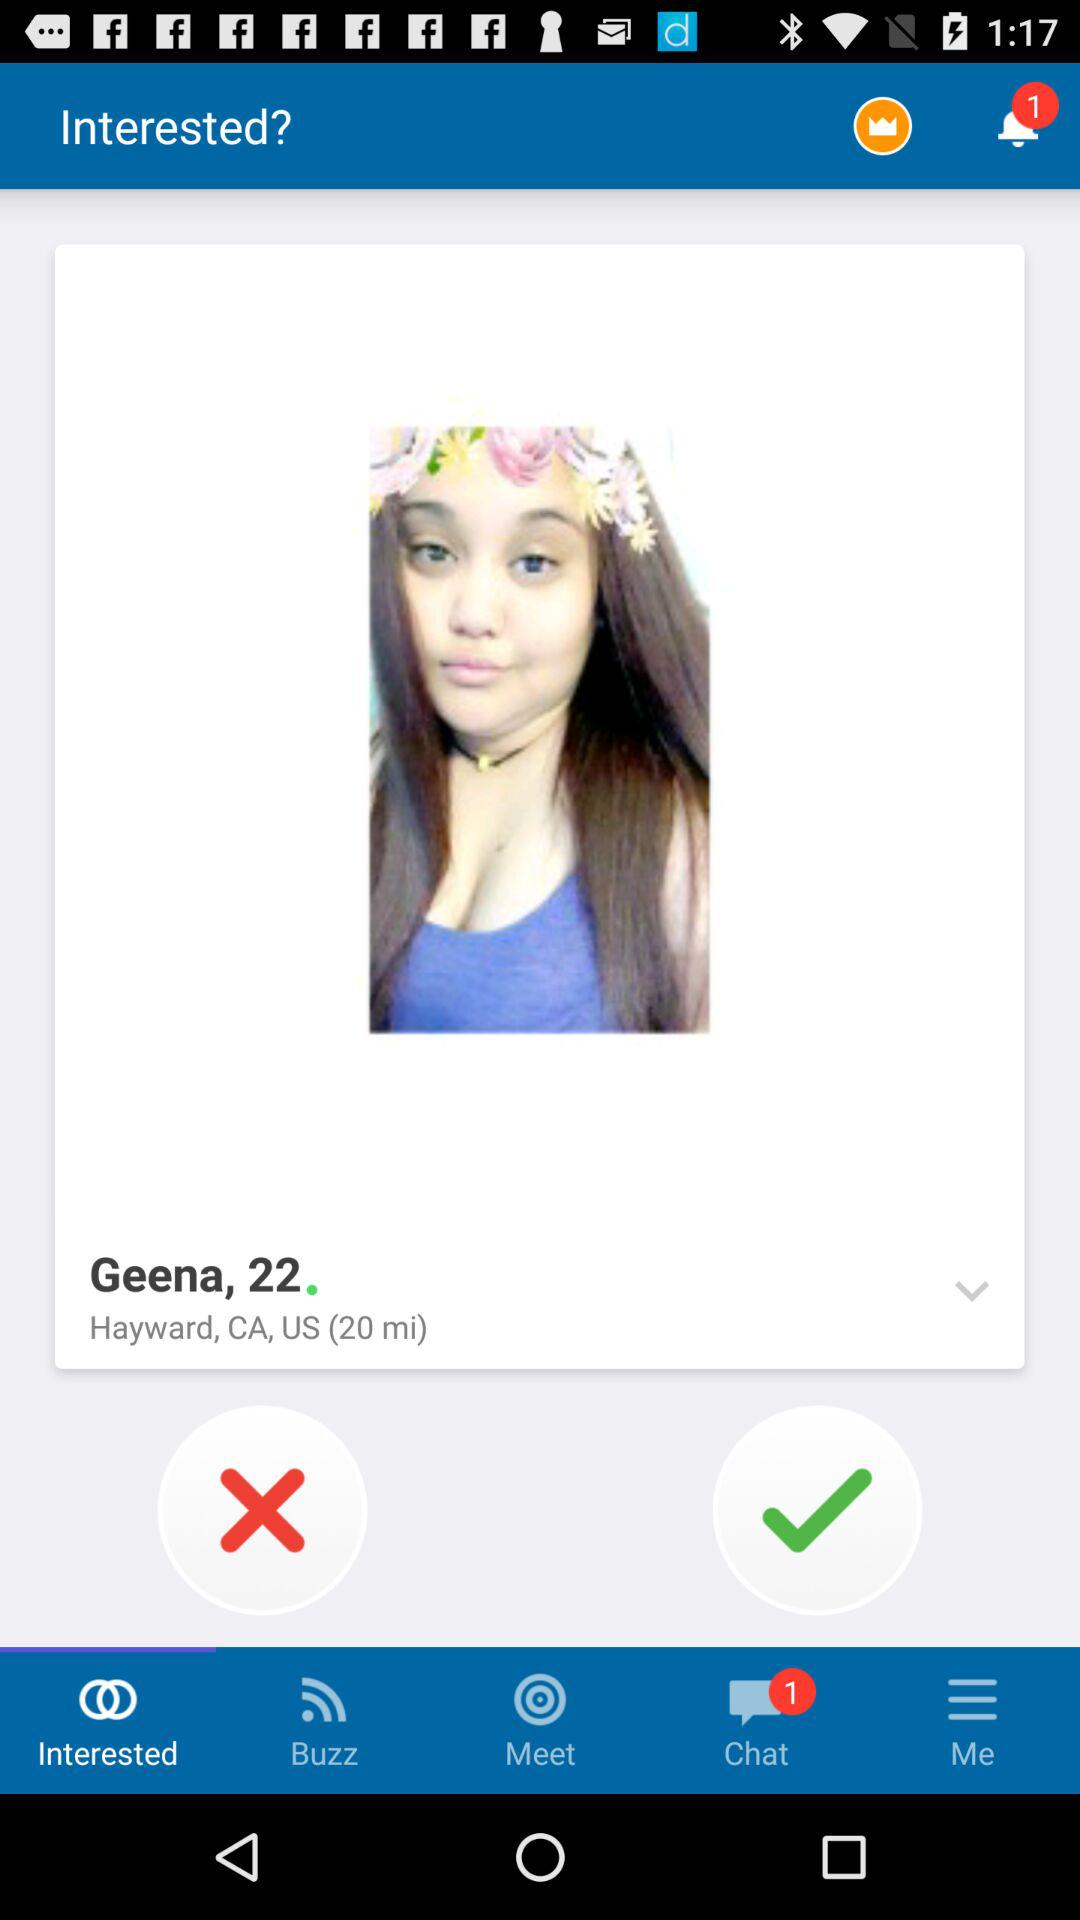What is the user name? The user name is Geena. 